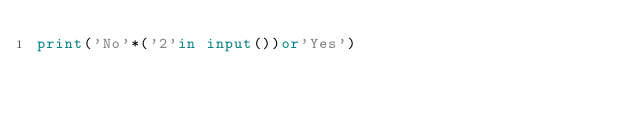<code> <loc_0><loc_0><loc_500><loc_500><_Python_>print('No'*('2'in input())or'Yes')</code> 